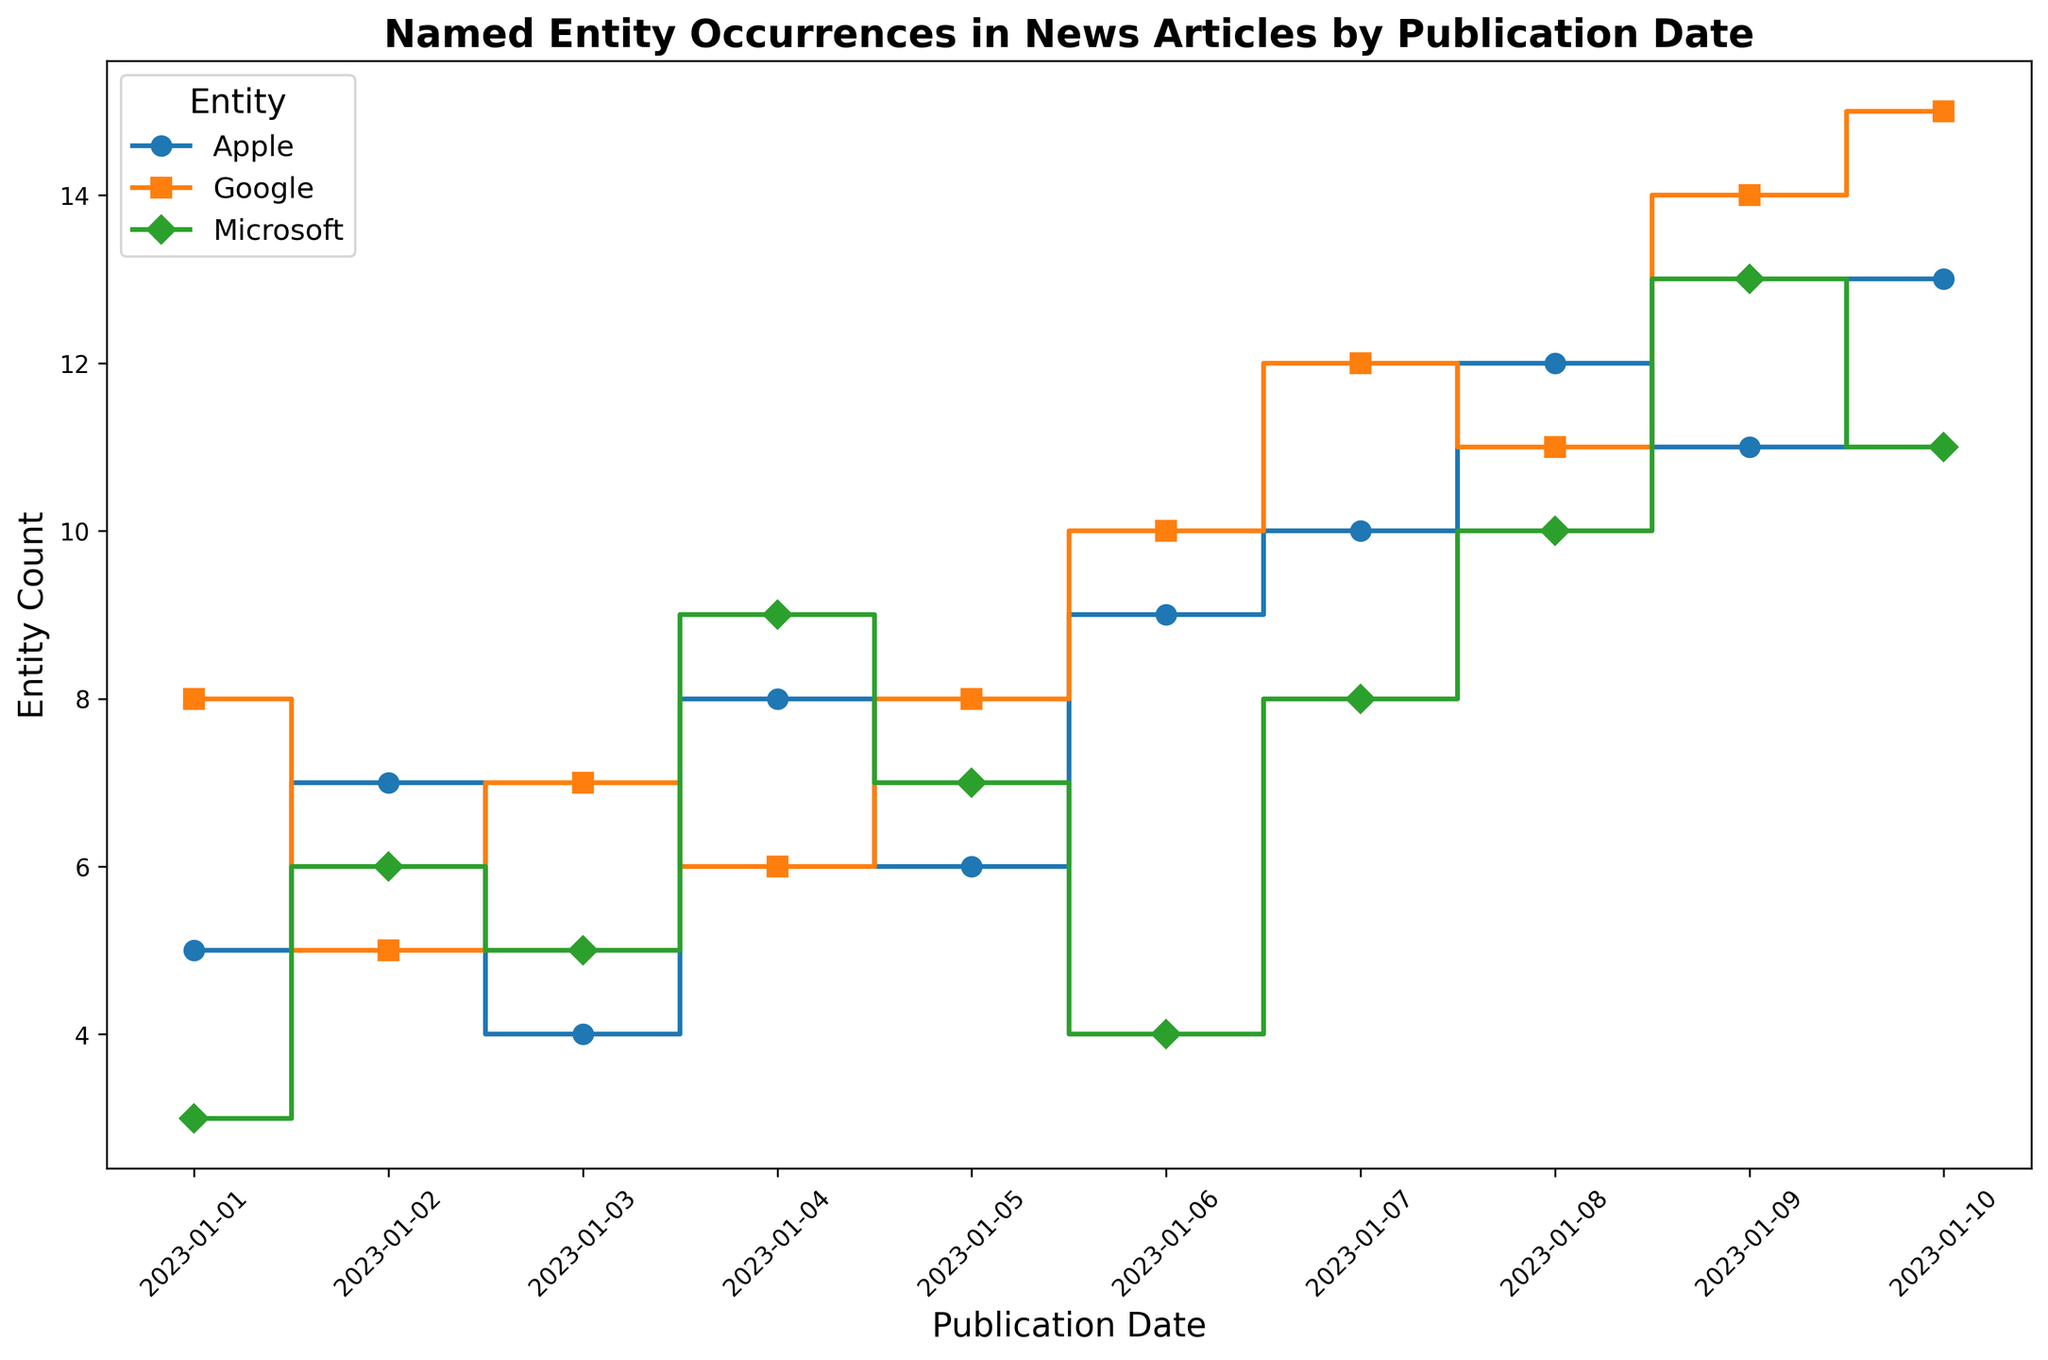Which entity has the highest occurrence on January 10? On January 10, the plot shows the lines corresponding to the different entities. The count for 'Google' is the highest as it reaches 15.
Answer: Google Between which dates does the count of 'Microsoft' show a steady increase? Look at the 'Microsoft' line which starts increasing steadily from January 1 to January 9 without any decline.
Answer: January 1 to January 9 What is the combined count of 'Apple' and 'Google' on January 8? On January 8, the count of 'Apple' is 12 and the count of 'Google' is 11. Combined, it is 12 + 11.
Answer: 23 How does the trend of 'Apple' occurrences compare to 'Microsoft' between January 1 and January 9? From January 1 to January 9, 'Apple' shows an up-and-down pattern but generally increases, while 'Microsoft' steadily increases, surpassing 'Apple' around January 9.
Answer: Apple's trend is more fluctuating, while Microsoft's trend is steadily increasing What is the difference in occurrences of 'Google' between January 3 and January 9? On January 3, 'Google' has 7 occurrences, and on January 9, 'Google' increases to 14 occurrences. The difference is 14 - 7.
Answer: 7 Which entity shows the most variability in its occurrences over the time period? By observing the fluctuations in the stairs plot, 'Google' shows more significant peaks and valleys compared to 'Apple' and 'Microsoft'.
Answer: Google On which date does 'Apple' first reach double digits in occurrences? The 'Apple' line reaches double digits on January 7.
Answer: January 7 What is the average count of 'Microsoft' from January 1 to January 10? Sum the counts from January 1 to January 10 for 'Microsoft' (3 + 6 + 5 + 9 + 7 + 4 + 8 + 10 + 13 + 11 = 76) and divide by the number of days (10).
Answer: 7.6 Compare the highest occurrence counts of 'Apple' and 'Google'. Which is higher and by how much? The highest occurrence count for 'Apple' is 13 (January 10) and for 'Google' is 15 (January 10). The difference is 15 - 13.
Answer: 'Google' by 2 